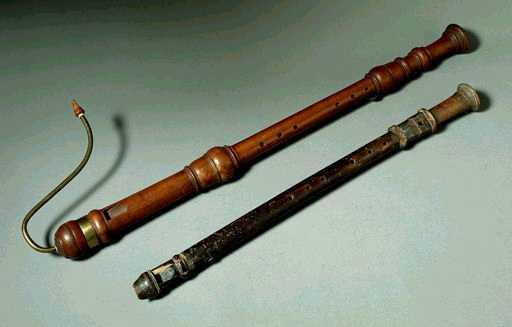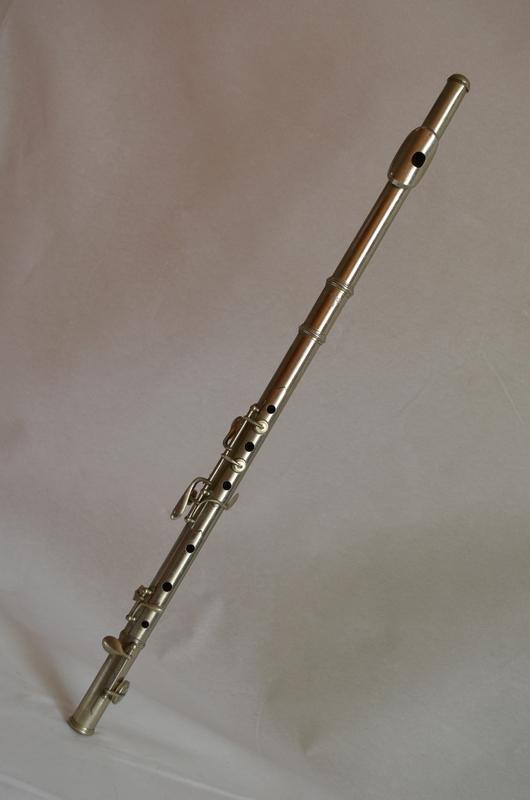The first image is the image on the left, the second image is the image on the right. Analyze the images presented: Is the assertion "The left image contains at least two musical instruments." valid? Answer yes or no. Yes. The first image is the image on the left, the second image is the image on the right. For the images displayed, is the sentence "No image contains more than one instrument, and one instrument is light wood with holes down its length, and the other is silver with small button-keys on tabs." factually correct? Answer yes or no. No. 